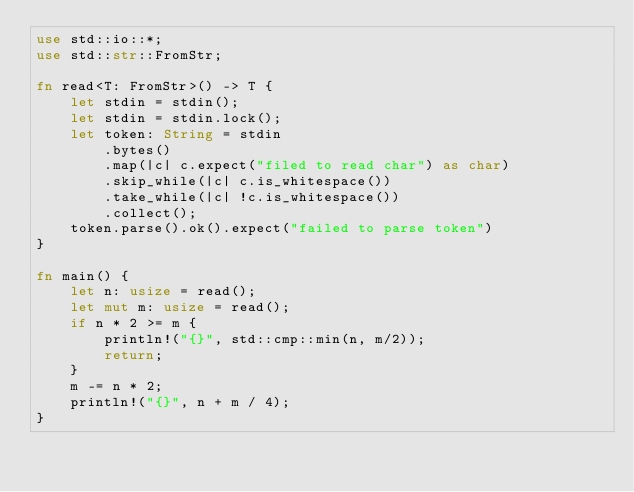<code> <loc_0><loc_0><loc_500><loc_500><_Rust_>use std::io::*;
use std::str::FromStr;

fn read<T: FromStr>() -> T {
    let stdin = stdin();
    let stdin = stdin.lock();
    let token: String = stdin
        .bytes()
        .map(|c| c.expect("filed to read char") as char)
        .skip_while(|c| c.is_whitespace())
        .take_while(|c| !c.is_whitespace())
        .collect();
    token.parse().ok().expect("failed to parse token")
}

fn main() {
    let n: usize = read();
    let mut m: usize = read();
    if n * 2 >= m {
        println!("{}", std::cmp::min(n, m/2));
        return;
    }
    m -= n * 2;
    println!("{}", n + m / 4);
}</code> 